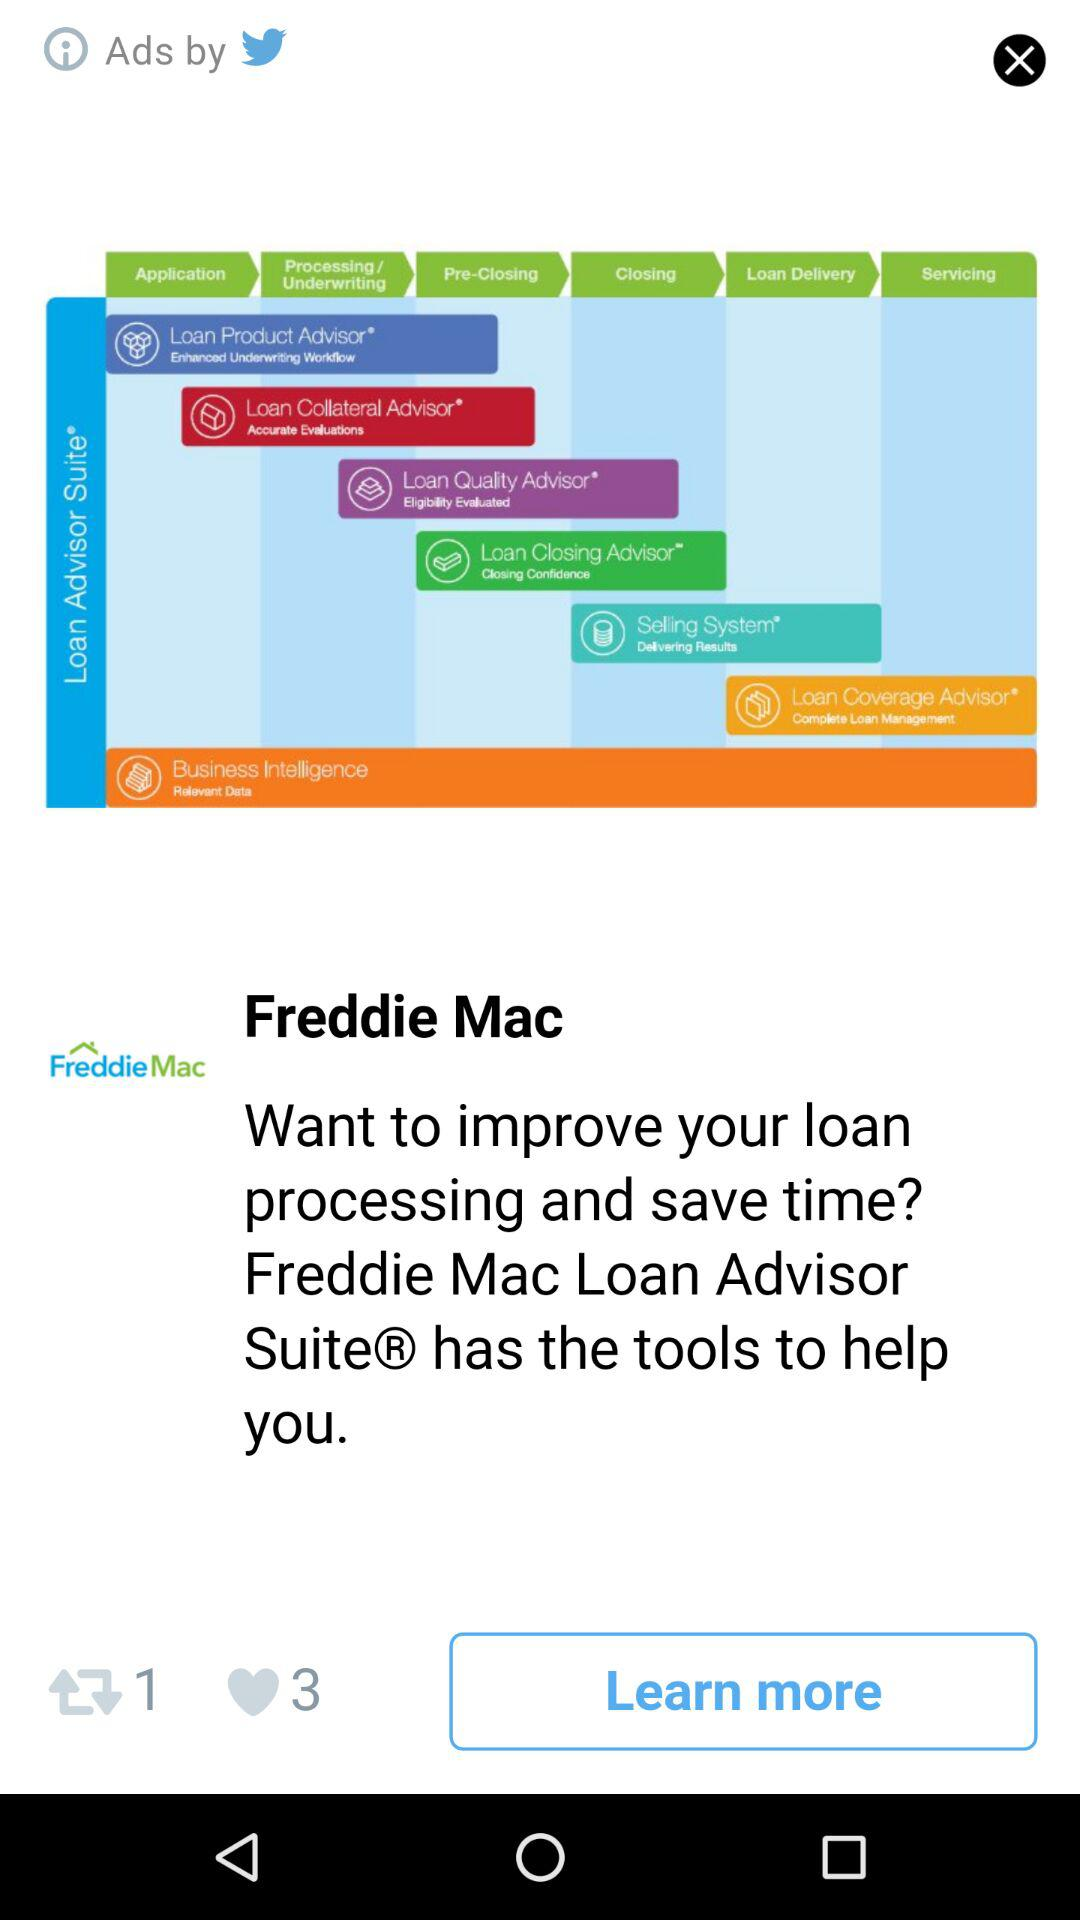How many likes are there? There are 3 likes. 